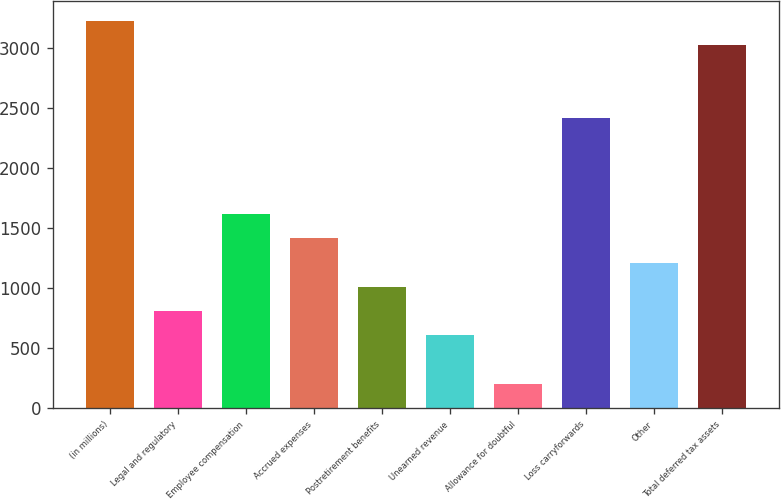Convert chart to OTSL. <chart><loc_0><loc_0><loc_500><loc_500><bar_chart><fcel>(in millions)<fcel>Legal and regulatory<fcel>Employee compensation<fcel>Accrued expenses<fcel>Postretirement benefits<fcel>Unearned revenue<fcel>Allowance for doubtful<fcel>Loss carryforwards<fcel>Other<fcel>Total deferred tax assets<nl><fcel>3224.8<fcel>809.2<fcel>1614.4<fcel>1413.1<fcel>1010.5<fcel>607.9<fcel>205.3<fcel>2419.6<fcel>1211.8<fcel>3023.5<nl></chart> 